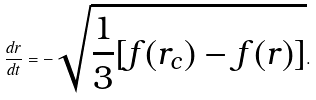Convert formula to latex. <formula><loc_0><loc_0><loc_500><loc_500>\frac { d r } { d t } = - \sqrt { \frac { 1 } { 3 } [ f ( r _ { c } ) - f ( r ) ] } .</formula> 